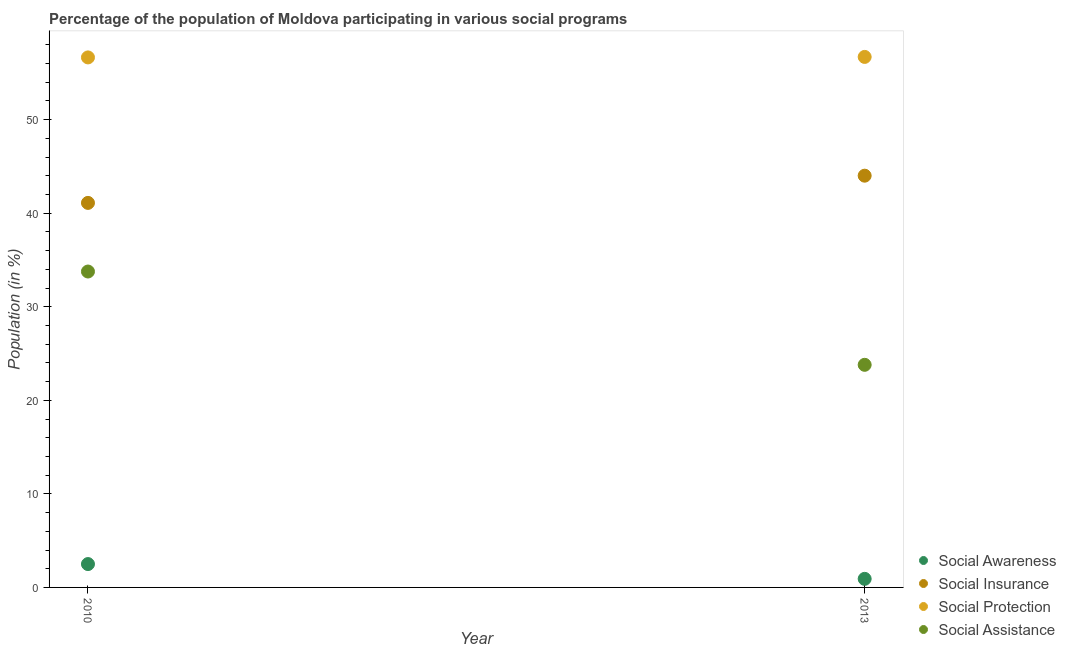How many different coloured dotlines are there?
Keep it short and to the point. 4. What is the participation of population in social assistance programs in 2010?
Provide a short and direct response. 33.76. Across all years, what is the maximum participation of population in social insurance programs?
Give a very brief answer. 44.01. Across all years, what is the minimum participation of population in social protection programs?
Offer a very short reply. 56.65. What is the total participation of population in social awareness programs in the graph?
Provide a succinct answer. 3.41. What is the difference between the participation of population in social awareness programs in 2010 and that in 2013?
Provide a succinct answer. 1.58. What is the difference between the participation of population in social protection programs in 2010 and the participation of population in social awareness programs in 2013?
Your answer should be very brief. 55.73. What is the average participation of population in social protection programs per year?
Your answer should be very brief. 56.67. In the year 2013, what is the difference between the participation of population in social protection programs and participation of population in social assistance programs?
Ensure brevity in your answer.  32.91. What is the ratio of the participation of population in social protection programs in 2010 to that in 2013?
Ensure brevity in your answer.  1. Is the participation of population in social insurance programs in 2010 less than that in 2013?
Your answer should be very brief. Yes. Is the participation of population in social awareness programs strictly less than the participation of population in social assistance programs over the years?
Your response must be concise. Yes. Does the graph contain grids?
Provide a succinct answer. No. Where does the legend appear in the graph?
Your answer should be compact. Bottom right. How many legend labels are there?
Ensure brevity in your answer.  4. What is the title of the graph?
Your answer should be very brief. Percentage of the population of Moldova participating in various social programs . Does "Public resource use" appear as one of the legend labels in the graph?
Your response must be concise. No. What is the label or title of the X-axis?
Provide a succinct answer. Year. What is the Population (in %) of Social Awareness in 2010?
Provide a short and direct response. 2.5. What is the Population (in %) of Social Insurance in 2010?
Make the answer very short. 41.1. What is the Population (in %) of Social Protection in 2010?
Your answer should be very brief. 56.65. What is the Population (in %) of Social Assistance in 2010?
Keep it short and to the point. 33.76. What is the Population (in %) of Social Awareness in 2013?
Make the answer very short. 0.92. What is the Population (in %) in Social Insurance in 2013?
Offer a very short reply. 44.01. What is the Population (in %) in Social Protection in 2013?
Offer a very short reply. 56.7. What is the Population (in %) of Social Assistance in 2013?
Your answer should be very brief. 23.79. Across all years, what is the maximum Population (in %) in Social Awareness?
Make the answer very short. 2.5. Across all years, what is the maximum Population (in %) of Social Insurance?
Your answer should be compact. 44.01. Across all years, what is the maximum Population (in %) in Social Protection?
Provide a succinct answer. 56.7. Across all years, what is the maximum Population (in %) in Social Assistance?
Keep it short and to the point. 33.76. Across all years, what is the minimum Population (in %) in Social Awareness?
Your answer should be very brief. 0.92. Across all years, what is the minimum Population (in %) in Social Insurance?
Provide a succinct answer. 41.1. Across all years, what is the minimum Population (in %) in Social Protection?
Provide a short and direct response. 56.65. Across all years, what is the minimum Population (in %) of Social Assistance?
Give a very brief answer. 23.79. What is the total Population (in %) in Social Awareness in the graph?
Offer a terse response. 3.41. What is the total Population (in %) of Social Insurance in the graph?
Give a very brief answer. 85.1. What is the total Population (in %) of Social Protection in the graph?
Provide a succinct answer. 113.35. What is the total Population (in %) of Social Assistance in the graph?
Offer a terse response. 57.56. What is the difference between the Population (in %) of Social Awareness in 2010 and that in 2013?
Give a very brief answer. 1.58. What is the difference between the Population (in %) in Social Insurance in 2010 and that in 2013?
Keep it short and to the point. -2.91. What is the difference between the Population (in %) in Social Protection in 2010 and that in 2013?
Your response must be concise. -0.05. What is the difference between the Population (in %) in Social Assistance in 2010 and that in 2013?
Make the answer very short. 9.97. What is the difference between the Population (in %) in Social Awareness in 2010 and the Population (in %) in Social Insurance in 2013?
Offer a terse response. -41.51. What is the difference between the Population (in %) in Social Awareness in 2010 and the Population (in %) in Social Protection in 2013?
Your answer should be compact. -54.2. What is the difference between the Population (in %) of Social Awareness in 2010 and the Population (in %) of Social Assistance in 2013?
Keep it short and to the point. -21.3. What is the difference between the Population (in %) in Social Insurance in 2010 and the Population (in %) in Social Protection in 2013?
Give a very brief answer. -15.6. What is the difference between the Population (in %) in Social Insurance in 2010 and the Population (in %) in Social Assistance in 2013?
Your response must be concise. 17.31. What is the difference between the Population (in %) of Social Protection in 2010 and the Population (in %) of Social Assistance in 2013?
Offer a very short reply. 32.85. What is the average Population (in %) in Social Awareness per year?
Keep it short and to the point. 1.71. What is the average Population (in %) of Social Insurance per year?
Provide a succinct answer. 42.55. What is the average Population (in %) of Social Protection per year?
Your answer should be very brief. 56.67. What is the average Population (in %) of Social Assistance per year?
Your answer should be very brief. 28.78. In the year 2010, what is the difference between the Population (in %) of Social Awareness and Population (in %) of Social Insurance?
Your answer should be very brief. -38.6. In the year 2010, what is the difference between the Population (in %) in Social Awareness and Population (in %) in Social Protection?
Offer a very short reply. -54.15. In the year 2010, what is the difference between the Population (in %) in Social Awareness and Population (in %) in Social Assistance?
Give a very brief answer. -31.27. In the year 2010, what is the difference between the Population (in %) of Social Insurance and Population (in %) of Social Protection?
Ensure brevity in your answer.  -15.55. In the year 2010, what is the difference between the Population (in %) in Social Insurance and Population (in %) in Social Assistance?
Offer a terse response. 7.33. In the year 2010, what is the difference between the Population (in %) in Social Protection and Population (in %) in Social Assistance?
Ensure brevity in your answer.  22.88. In the year 2013, what is the difference between the Population (in %) of Social Awareness and Population (in %) of Social Insurance?
Provide a succinct answer. -43.09. In the year 2013, what is the difference between the Population (in %) of Social Awareness and Population (in %) of Social Protection?
Your answer should be compact. -55.78. In the year 2013, what is the difference between the Population (in %) in Social Awareness and Population (in %) in Social Assistance?
Give a very brief answer. -22.88. In the year 2013, what is the difference between the Population (in %) of Social Insurance and Population (in %) of Social Protection?
Your answer should be very brief. -12.69. In the year 2013, what is the difference between the Population (in %) of Social Insurance and Population (in %) of Social Assistance?
Offer a terse response. 20.21. In the year 2013, what is the difference between the Population (in %) in Social Protection and Population (in %) in Social Assistance?
Keep it short and to the point. 32.91. What is the ratio of the Population (in %) of Social Awareness in 2010 to that in 2013?
Offer a very short reply. 2.73. What is the ratio of the Population (in %) in Social Insurance in 2010 to that in 2013?
Your response must be concise. 0.93. What is the ratio of the Population (in %) of Social Assistance in 2010 to that in 2013?
Keep it short and to the point. 1.42. What is the difference between the highest and the second highest Population (in %) in Social Awareness?
Keep it short and to the point. 1.58. What is the difference between the highest and the second highest Population (in %) in Social Insurance?
Make the answer very short. 2.91. What is the difference between the highest and the second highest Population (in %) of Social Protection?
Your answer should be compact. 0.05. What is the difference between the highest and the second highest Population (in %) of Social Assistance?
Make the answer very short. 9.97. What is the difference between the highest and the lowest Population (in %) in Social Awareness?
Your response must be concise. 1.58. What is the difference between the highest and the lowest Population (in %) in Social Insurance?
Make the answer very short. 2.91. What is the difference between the highest and the lowest Population (in %) in Social Protection?
Your response must be concise. 0.05. What is the difference between the highest and the lowest Population (in %) in Social Assistance?
Offer a very short reply. 9.97. 